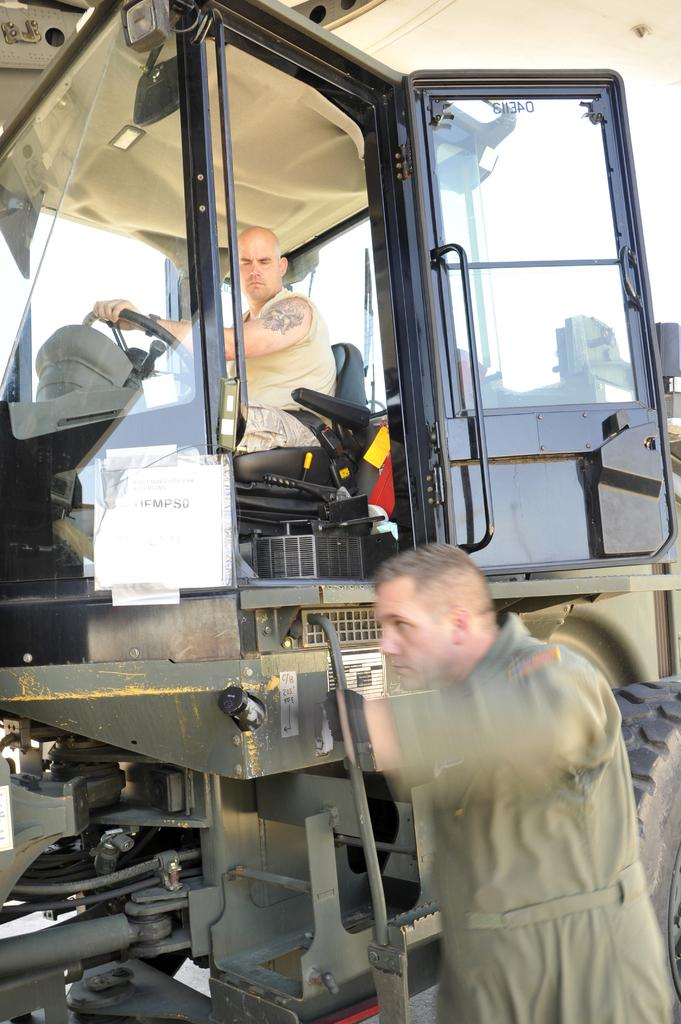What is the main subject of the image? There is a person sitting inside a vehicle in the image. Can you describe the person's surroundings? There is another person beside the vehicle. What can be seen in the background of the image? The sky is visible in the background of the image. How many dogs are visible in the image? There are no dogs present in the image. What angle is the hammer being held at in the image? There is no hammer present in the image. 